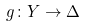Convert formula to latex. <formula><loc_0><loc_0><loc_500><loc_500>g \colon Y \rightarrow \Delta</formula> 